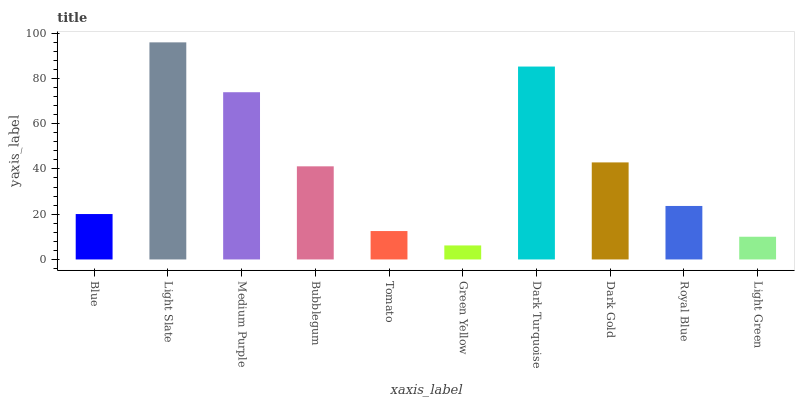Is Medium Purple the minimum?
Answer yes or no. No. Is Medium Purple the maximum?
Answer yes or no. No. Is Light Slate greater than Medium Purple?
Answer yes or no. Yes. Is Medium Purple less than Light Slate?
Answer yes or no. Yes. Is Medium Purple greater than Light Slate?
Answer yes or no. No. Is Light Slate less than Medium Purple?
Answer yes or no. No. Is Bubblegum the high median?
Answer yes or no. Yes. Is Royal Blue the low median?
Answer yes or no. Yes. Is Light Green the high median?
Answer yes or no. No. Is Tomato the low median?
Answer yes or no. No. 